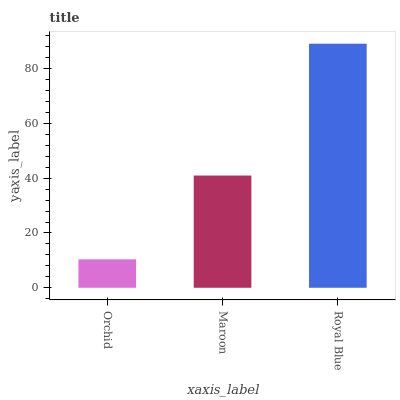Is Orchid the minimum?
Answer yes or no. Yes. Is Royal Blue the maximum?
Answer yes or no. Yes. Is Maroon the minimum?
Answer yes or no. No. Is Maroon the maximum?
Answer yes or no. No. Is Maroon greater than Orchid?
Answer yes or no. Yes. Is Orchid less than Maroon?
Answer yes or no. Yes. Is Orchid greater than Maroon?
Answer yes or no. No. Is Maroon less than Orchid?
Answer yes or no. No. Is Maroon the high median?
Answer yes or no. Yes. Is Maroon the low median?
Answer yes or no. Yes. Is Orchid the high median?
Answer yes or no. No. Is Orchid the low median?
Answer yes or no. No. 